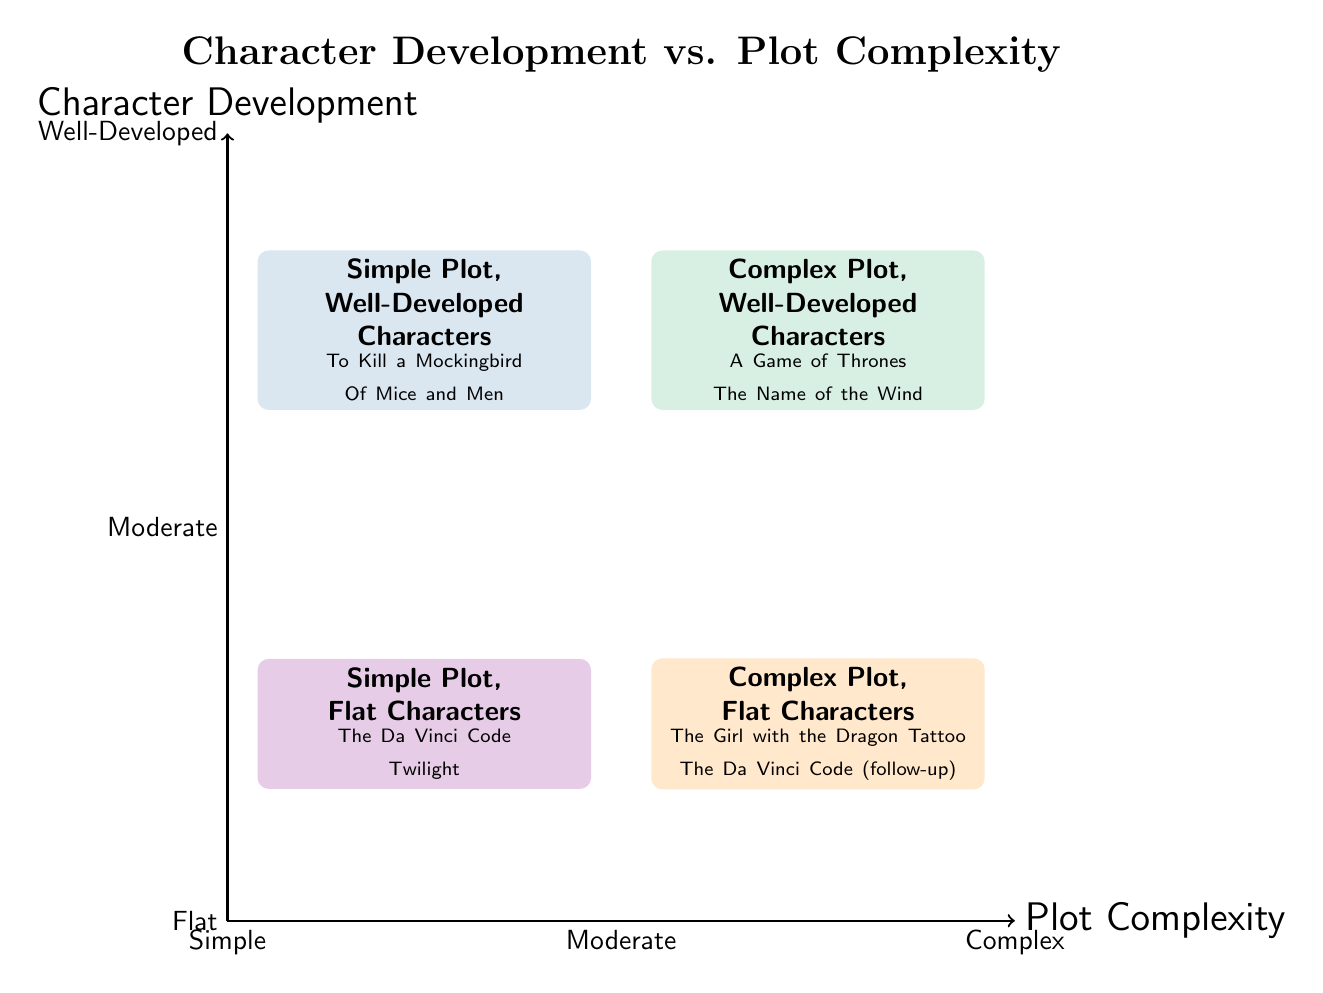What types of characters are found in the Simple Plot, Well-Developed Characters quadrant? The diagram indicates that this quadrant contains well-developed characters, as labeled. Two examples given are "To Kill a Mockingbird" and "Of Mice and Men," which are known for their rich character development despite having simple plots.
Answer: Well-Developed Which authors are associated with the Complex Plot, Flat Characters quadrant? The diagram lists two examples in this quadrant: "The Girl with the Dragon Tattoo" and "The Da Vinci Code (follow-up)," both authored by Stieg Larsson and Dan Brown, respectively. This indicates that these works have complex plots but flat characters.
Answer: Stieg Larsson and Dan Brown What is the title of the quadrant that features a Simple Plot and Flat Characters? The quadrant is labeled "Simple Plot, Flat Characters," which describes the combination of simple storytelling and underdeveloped characters, as seen in the examples provided.
Answer: Simple Plot, Flat Characters How many quadrants are there in the diagram? The diagram is divided into four distinct quadrants, each representing a combination of character development and plot complexity.
Answer: Four What can be inferred about the relationship between plot complexity and character development? The quadrants categorize works based on whether they feature complex or simple plots alongside flat or well-developed characters, suggesting a varied spectrum. For example, the top quadrants contain well-developed characters, while the bottom quadrants contain flat characters, indicating a decrease in character depth as plot complexity increases in the bottom quadrants.
Answer: Varied spectrum What examples are found in the Complex Plot, Well-Developed Characters quadrant? The examples listed in this quadrant include "A Game of Thrones" and "The Name of the Wind," both of which are known for their intricate plots and rich character experiences.
Answer: A Game of Thrones, The Name of the Wind In which quadrant does "Twilight" appear? The diagram positions "Twilight" in the "Simple Plot, Flat Characters" quadrant, highlighting its combination of straightforward storytelling coupled with less character depth.
Answer: Simple Plot, Flat Characters What conclusion can be drawn about character development in the Simple Plot, Well-Developed Characters quadrant versus the Complex Plot, Flat Characters quadrant? In the Simple Plot, Well-Developed Characters quadrant, stories balance simplicity in plot with depth in character, while in the Complex Plot, Flat Characters quadrant, the complexity of plot does not translate to character depth, implying that intricate storytelling alone is not sufficient for character richness.
Answer: Balance vs. Lack of Depth 